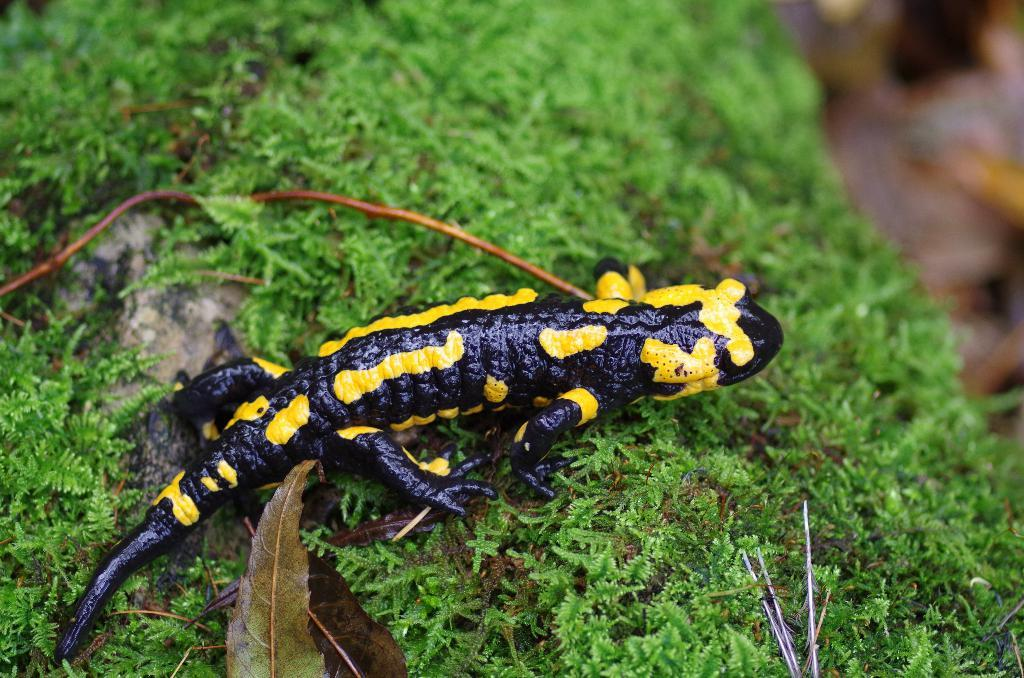What type of animal is in the picture? There is a reptile in the picture. Where is the reptile located in the image? The reptile is on the leaves. What is the condition of the wooden fence in the image? There is no wooden fence present in the image; it only features a reptile on the leaves. 